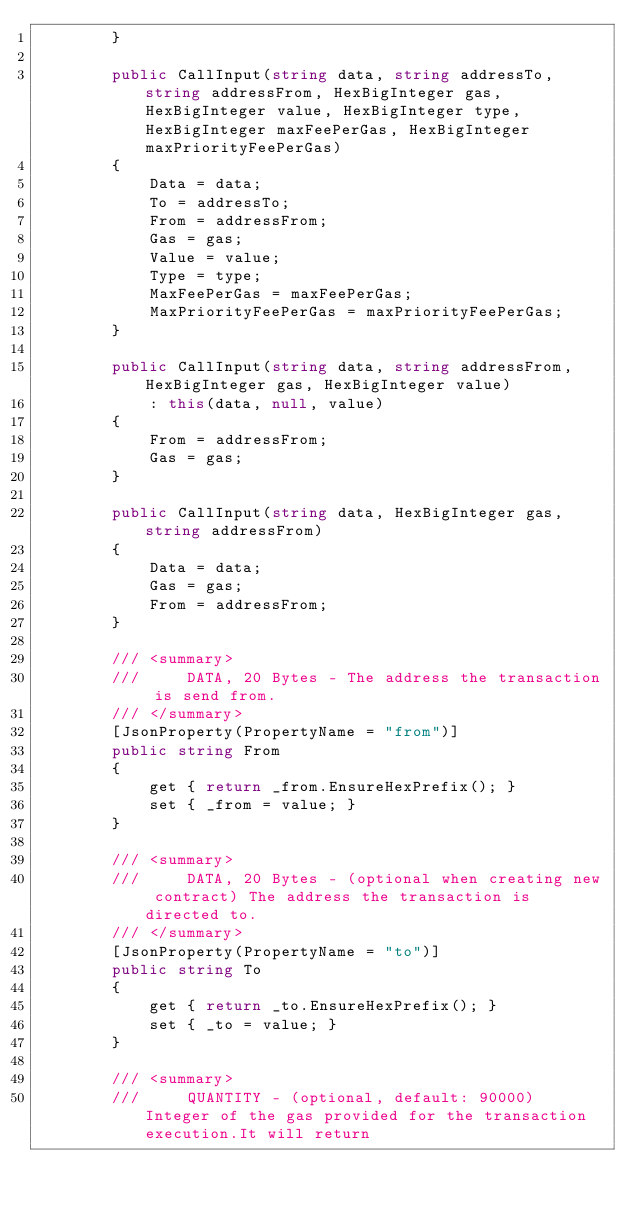<code> <loc_0><loc_0><loc_500><loc_500><_C#_>        }

        public CallInput(string data, string addressTo, string addressFrom, HexBigInteger gas, HexBigInteger value, HexBigInteger type, HexBigInteger maxFeePerGas, HexBigInteger maxPriorityFeePerGas)
        {
            Data = data;
            To = addressTo;
            From = addressFrom;
            Gas = gas;
            Value = value;
            Type = type;
            MaxFeePerGas = maxFeePerGas;
            MaxPriorityFeePerGas = maxPriorityFeePerGas;
        }

        public CallInput(string data, string addressFrom, HexBigInteger gas, HexBigInteger value)
            : this(data, null, value)
        {
            From = addressFrom;
            Gas = gas;
        }

        public CallInput(string data, HexBigInteger gas, string addressFrom)
        {
            Data = data;
            Gas = gas;
            From = addressFrom;
        }

        /// <summary>
        ///     DATA, 20 Bytes - The address the transaction is send from.
        /// </summary>
        [JsonProperty(PropertyName = "from")]
        public string From
        {
            get { return _from.EnsureHexPrefix(); }
            set { _from = value; }
        }

        /// <summary>
        ///     DATA, 20 Bytes - (optional when creating new contract) The address the transaction is directed to.
        /// </summary>
        [JsonProperty(PropertyName = "to")]
        public string To
        {
            get { return _to.EnsureHexPrefix(); }
            set { _to = value; }
        }

        /// <summary>
        ///     QUANTITY - (optional, default: 90000) Integer of the gas provided for the transaction execution.It will return</code> 